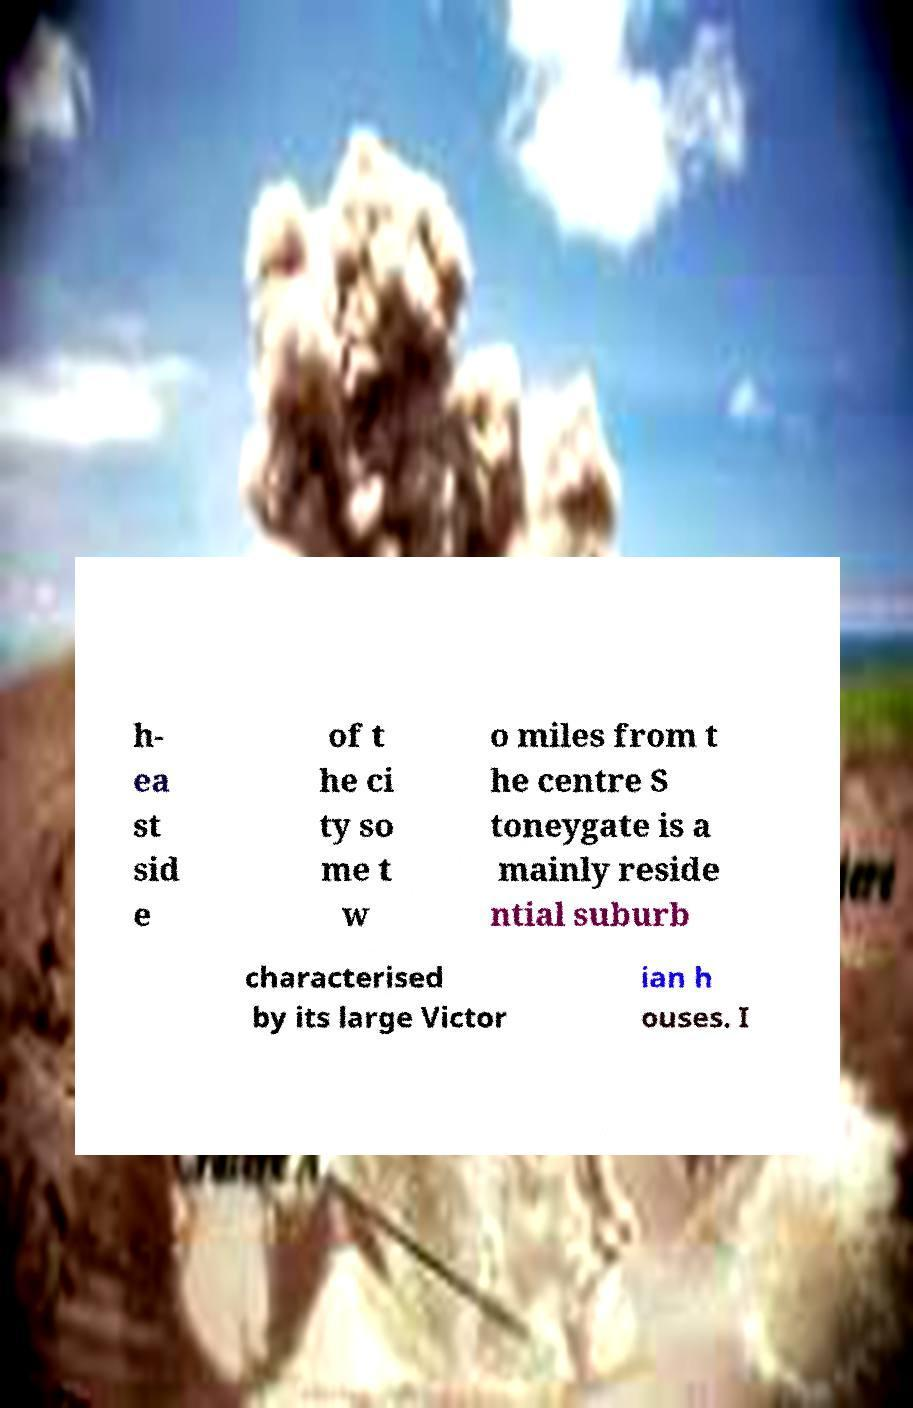Please read and relay the text visible in this image. What does it say? h- ea st sid e of t he ci ty so me t w o miles from t he centre S toneygate is a mainly reside ntial suburb characterised by its large Victor ian h ouses. I 